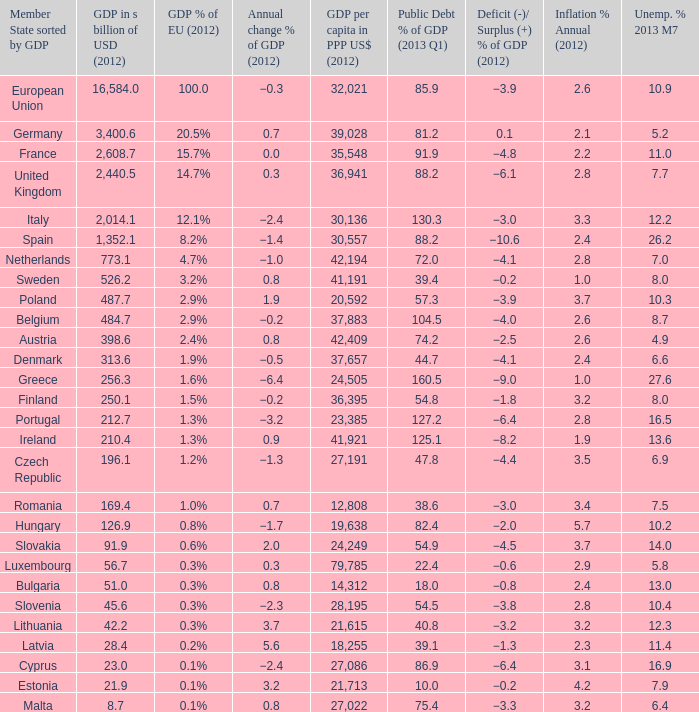What is the average public debt % of GDP in 2013 Q1 of the country with a member slate sorted by GDP of Czech Republic and a GDP per capita in PPP US dollars in 2012 greater than 27,191? None. Would you mind parsing the complete table? {'header': ['Member State sorted by GDP', 'GDP in s billion of USD (2012)', 'GDP % of EU (2012)', 'Annual change % of GDP (2012)', 'GDP per capita in PPP US$ (2012)', 'Public Debt % of GDP (2013 Q1)', 'Deficit (-)/ Surplus (+) % of GDP (2012)', 'Inflation % Annual (2012)', 'Unemp. % 2013 M7'], 'rows': [['European Union', '16,584.0', '100.0', '−0.3', '32,021', '85.9', '−3.9', '2.6', '10.9'], ['Germany', '3,400.6', '20.5%', '0.7', '39,028', '81.2', '0.1', '2.1', '5.2'], ['France', '2,608.7', '15.7%', '0.0', '35,548', '91.9', '−4.8', '2.2', '11.0'], ['United Kingdom', '2,440.5', '14.7%', '0.3', '36,941', '88.2', '−6.1', '2.8', '7.7'], ['Italy', '2,014.1', '12.1%', '−2.4', '30,136', '130.3', '−3.0', '3.3', '12.2'], ['Spain', '1,352.1', '8.2%', '−1.4', '30,557', '88.2', '−10.6', '2.4', '26.2'], ['Netherlands', '773.1', '4.7%', '−1.0', '42,194', '72.0', '−4.1', '2.8', '7.0'], ['Sweden', '526.2', '3.2%', '0.8', '41,191', '39.4', '−0.2', '1.0', '8.0'], ['Poland', '487.7', '2.9%', '1.9', '20,592', '57.3', '−3.9', '3.7', '10.3'], ['Belgium', '484.7', '2.9%', '−0.2', '37,883', '104.5', '−4.0', '2.6', '8.7'], ['Austria', '398.6', '2.4%', '0.8', '42,409', '74.2', '−2.5', '2.6', '4.9'], ['Denmark', '313.6', '1.9%', '−0.5', '37,657', '44.7', '−4.1', '2.4', '6.6'], ['Greece', '256.3', '1.6%', '−6.4', '24,505', '160.5', '−9.0', '1.0', '27.6'], ['Finland', '250.1', '1.5%', '−0.2', '36,395', '54.8', '−1.8', '3.2', '8.0'], ['Portugal', '212.7', '1.3%', '−3.2', '23,385', '127.2', '−6.4', '2.8', '16.5'], ['Ireland', '210.4', '1.3%', '0.9', '41,921', '125.1', '−8.2', '1.9', '13.6'], ['Czech Republic', '196.1', '1.2%', '−1.3', '27,191', '47.8', '−4.4', '3.5', '6.9'], ['Romania', '169.4', '1.0%', '0.7', '12,808', '38.6', '−3.0', '3.4', '7.5'], ['Hungary', '126.9', '0.8%', '−1.7', '19,638', '82.4', '−2.0', '5.7', '10.2'], ['Slovakia', '91.9', '0.6%', '2.0', '24,249', '54.9', '−4.5', '3.7', '14.0'], ['Luxembourg', '56.7', '0.3%', '0.3', '79,785', '22.4', '−0.6', '2.9', '5.8'], ['Bulgaria', '51.0', '0.3%', '0.8', '14,312', '18.0', '−0.8', '2.4', '13.0'], ['Slovenia', '45.6', '0.3%', '−2.3', '28,195', '54.5', '−3.8', '2.8', '10.4'], ['Lithuania', '42.2', '0.3%', '3.7', '21,615', '40.8', '−3.2', '3.2', '12.3'], ['Latvia', '28.4', '0.2%', '5.6', '18,255', '39.1', '−1.3', '2.3', '11.4'], ['Cyprus', '23.0', '0.1%', '−2.4', '27,086', '86.9', '−6.4', '3.1', '16.9'], ['Estonia', '21.9', '0.1%', '3.2', '21,713', '10.0', '−0.2', '4.2', '7.9'], ['Malta', '8.7', '0.1%', '0.8', '27,022', '75.4', '−3.3', '3.2', '6.4']]} 